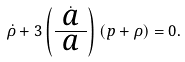Convert formula to latex. <formula><loc_0><loc_0><loc_500><loc_500>\dot { \rho } + 3 \left ( \frac { \dot { \emph { a } } } { \emph { a } } \right ) \left ( p + \rho \right ) = 0 .</formula> 